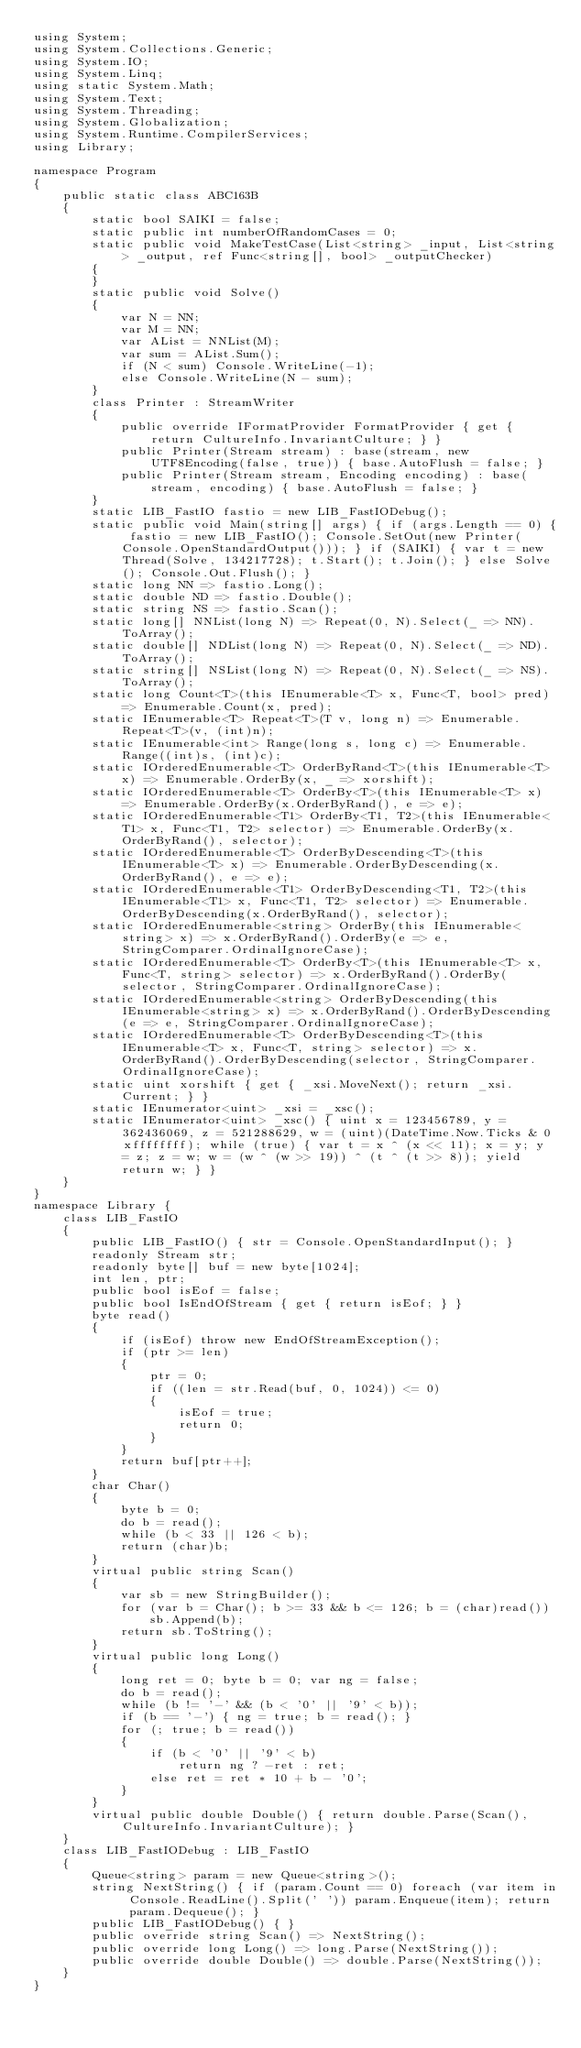<code> <loc_0><loc_0><loc_500><loc_500><_C#_>using System;
using System.Collections.Generic;
using System.IO;
using System.Linq;
using static System.Math;
using System.Text;
using System.Threading;
using System.Globalization;
using System.Runtime.CompilerServices;
using Library;

namespace Program
{
    public static class ABC163B
    {
        static bool SAIKI = false;
        static public int numberOfRandomCases = 0;
        static public void MakeTestCase(List<string> _input, List<string> _output, ref Func<string[], bool> _outputChecker)
        {
        }
        static public void Solve()
        {
            var N = NN;
            var M = NN;
            var AList = NNList(M);
            var sum = AList.Sum();
            if (N < sum) Console.WriteLine(-1);
            else Console.WriteLine(N - sum);
        }
        class Printer : StreamWriter
        {
            public override IFormatProvider FormatProvider { get { return CultureInfo.InvariantCulture; } }
            public Printer(Stream stream) : base(stream, new UTF8Encoding(false, true)) { base.AutoFlush = false; }
            public Printer(Stream stream, Encoding encoding) : base(stream, encoding) { base.AutoFlush = false; }
        }
        static LIB_FastIO fastio = new LIB_FastIODebug();
        static public void Main(string[] args) { if (args.Length == 0) { fastio = new LIB_FastIO(); Console.SetOut(new Printer(Console.OpenStandardOutput())); } if (SAIKI) { var t = new Thread(Solve, 134217728); t.Start(); t.Join(); } else Solve(); Console.Out.Flush(); }
        static long NN => fastio.Long();
        static double ND => fastio.Double();
        static string NS => fastio.Scan();
        static long[] NNList(long N) => Repeat(0, N).Select(_ => NN).ToArray();
        static double[] NDList(long N) => Repeat(0, N).Select(_ => ND).ToArray();
        static string[] NSList(long N) => Repeat(0, N).Select(_ => NS).ToArray();
        static long Count<T>(this IEnumerable<T> x, Func<T, bool> pred) => Enumerable.Count(x, pred);
        static IEnumerable<T> Repeat<T>(T v, long n) => Enumerable.Repeat<T>(v, (int)n);
        static IEnumerable<int> Range(long s, long c) => Enumerable.Range((int)s, (int)c);
        static IOrderedEnumerable<T> OrderByRand<T>(this IEnumerable<T> x) => Enumerable.OrderBy(x, _ => xorshift);
        static IOrderedEnumerable<T> OrderBy<T>(this IEnumerable<T> x) => Enumerable.OrderBy(x.OrderByRand(), e => e);
        static IOrderedEnumerable<T1> OrderBy<T1, T2>(this IEnumerable<T1> x, Func<T1, T2> selector) => Enumerable.OrderBy(x.OrderByRand(), selector);
        static IOrderedEnumerable<T> OrderByDescending<T>(this IEnumerable<T> x) => Enumerable.OrderByDescending(x.OrderByRand(), e => e);
        static IOrderedEnumerable<T1> OrderByDescending<T1, T2>(this IEnumerable<T1> x, Func<T1, T2> selector) => Enumerable.OrderByDescending(x.OrderByRand(), selector);
        static IOrderedEnumerable<string> OrderBy(this IEnumerable<string> x) => x.OrderByRand().OrderBy(e => e, StringComparer.OrdinalIgnoreCase);
        static IOrderedEnumerable<T> OrderBy<T>(this IEnumerable<T> x, Func<T, string> selector) => x.OrderByRand().OrderBy(selector, StringComparer.OrdinalIgnoreCase);
        static IOrderedEnumerable<string> OrderByDescending(this IEnumerable<string> x) => x.OrderByRand().OrderByDescending(e => e, StringComparer.OrdinalIgnoreCase);
        static IOrderedEnumerable<T> OrderByDescending<T>(this IEnumerable<T> x, Func<T, string> selector) => x.OrderByRand().OrderByDescending(selector, StringComparer.OrdinalIgnoreCase);
        static uint xorshift { get { _xsi.MoveNext(); return _xsi.Current; } }
        static IEnumerator<uint> _xsi = _xsc();
        static IEnumerator<uint> _xsc() { uint x = 123456789, y = 362436069, z = 521288629, w = (uint)(DateTime.Now.Ticks & 0xffffffff); while (true) { var t = x ^ (x << 11); x = y; y = z; z = w; w = (w ^ (w >> 19)) ^ (t ^ (t >> 8)); yield return w; } }
    }
}
namespace Library {
    class LIB_FastIO
    {
        public LIB_FastIO() { str = Console.OpenStandardInput(); }
        readonly Stream str;
        readonly byte[] buf = new byte[1024];
        int len, ptr;
        public bool isEof = false;
        public bool IsEndOfStream { get { return isEof; } }
        byte read()
        {
            if (isEof) throw new EndOfStreamException();
            if (ptr >= len)
            {
                ptr = 0;
                if ((len = str.Read(buf, 0, 1024)) <= 0)
                {
                    isEof = true;
                    return 0;
                }
            }
            return buf[ptr++];
        }
        char Char()
        {
            byte b = 0;
            do b = read();
            while (b < 33 || 126 < b);
            return (char)b;
        }
        virtual public string Scan()
        {
            var sb = new StringBuilder();
            for (var b = Char(); b >= 33 && b <= 126; b = (char)read())
                sb.Append(b);
            return sb.ToString();
        }
        virtual public long Long()
        {
            long ret = 0; byte b = 0; var ng = false;
            do b = read();
            while (b != '-' && (b < '0' || '9' < b));
            if (b == '-') { ng = true; b = read(); }
            for (; true; b = read())
            {
                if (b < '0' || '9' < b)
                    return ng ? -ret : ret;
                else ret = ret * 10 + b - '0';
            }
        }
        virtual public double Double() { return double.Parse(Scan(), CultureInfo.InvariantCulture); }
    }
    class LIB_FastIODebug : LIB_FastIO
    {
        Queue<string> param = new Queue<string>();
        string NextString() { if (param.Count == 0) foreach (var item in Console.ReadLine().Split(' ')) param.Enqueue(item); return param.Dequeue(); }
        public LIB_FastIODebug() { }
        public override string Scan() => NextString();
        public override long Long() => long.Parse(NextString());
        public override double Double() => double.Parse(NextString());
    }
}
</code> 